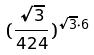<formula> <loc_0><loc_0><loc_500><loc_500>( \frac { \sqrt { 3 } } { 4 2 4 } ) ^ { \sqrt { 3 } \cdot 6 }</formula> 